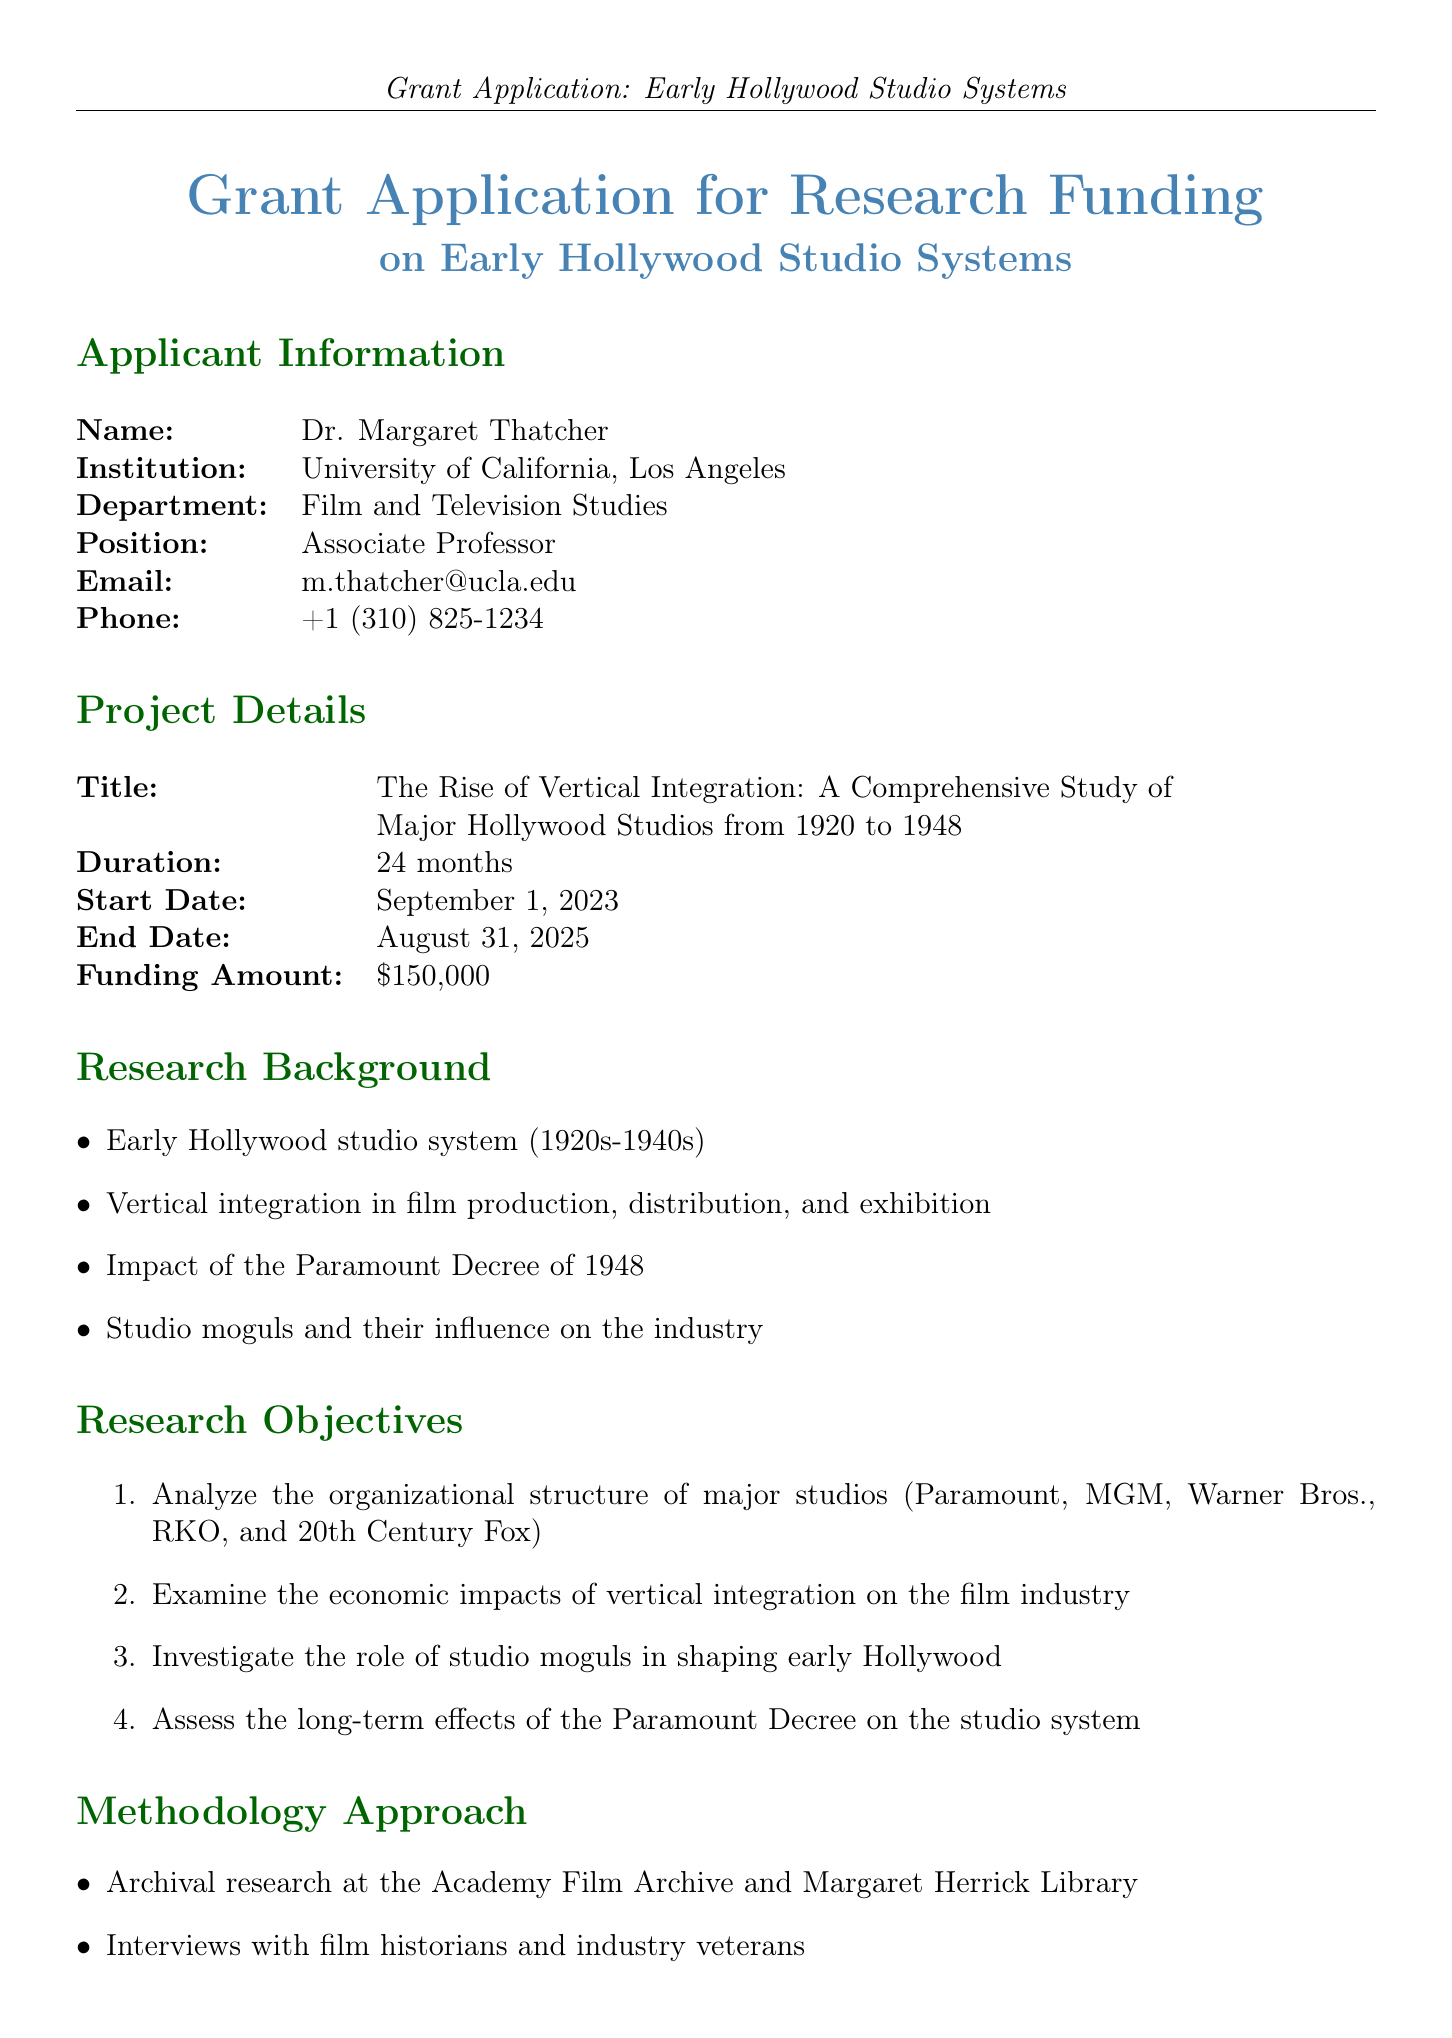What is the name of the applicant? The applicant's name is clearly stated at the beginning of the document.
Answer: Dr. Margaret Thatcher What is the title of the project? The title of the project is mentioned in the Project Details section.
Answer: The Rise of Vertical Integration: A Comprehensive Study of Major Hollywood Studios from 1920 to 1948 What is the start date of the project? The start date is specified in the Project Details section.
Answer: September 1, 2023 How long is the duration of the research project? The duration is listed in the Project Details section, indicating the period of research.
Answer: 24 months Which institution is the letter of support from? The document lists the institution in relation to the letter of support.
Answer: University of California, Los Angeles What are the total funding amount requested? The requested funding amount is explicitly stated in the Project Details section.
Answer: $150,000 How much is allocated for travel expenses? The budget breakdown in the document includes specific amounts for various categories.
Answer: $20,000 Who is serving as a consultant for the project? The role of the collaborator is noted in the Collaborators section.
Answer: Dr. Martin Scorsese What is the first research objective listed? The research objectives are listed in an enumerated format, where the first one can be clearly identified.
Answer: Analyze the organizational structure of major studios (Paramount, MGM, Warner Bros., RKO, and 20th Century Fox) 